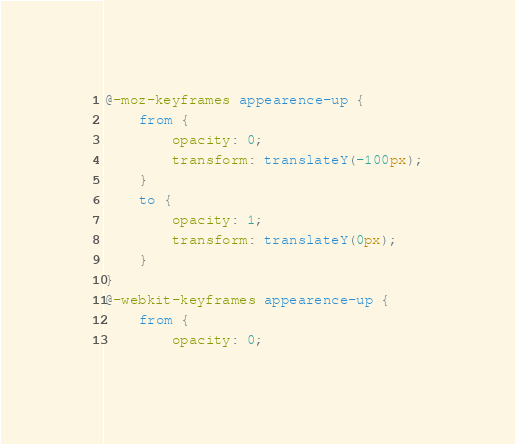<code> <loc_0><loc_0><loc_500><loc_500><_CSS_>@-moz-keyframes appearence-up {
    from {
        opacity: 0;
        transform: translateY(-100px);
    }
    to {
        opacity: 1;
        transform: translateY(0px);
    }
}
@-webkit-keyframes appearence-up {
    from {
        opacity: 0;</code> 